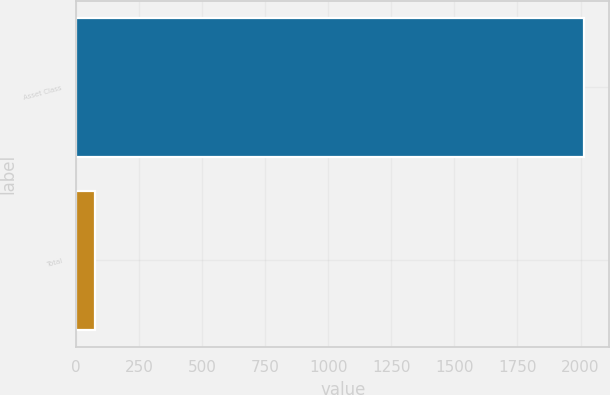Convert chart. <chart><loc_0><loc_0><loc_500><loc_500><bar_chart><fcel>Asset Class<fcel>Total<nl><fcel>2014<fcel>74<nl></chart> 